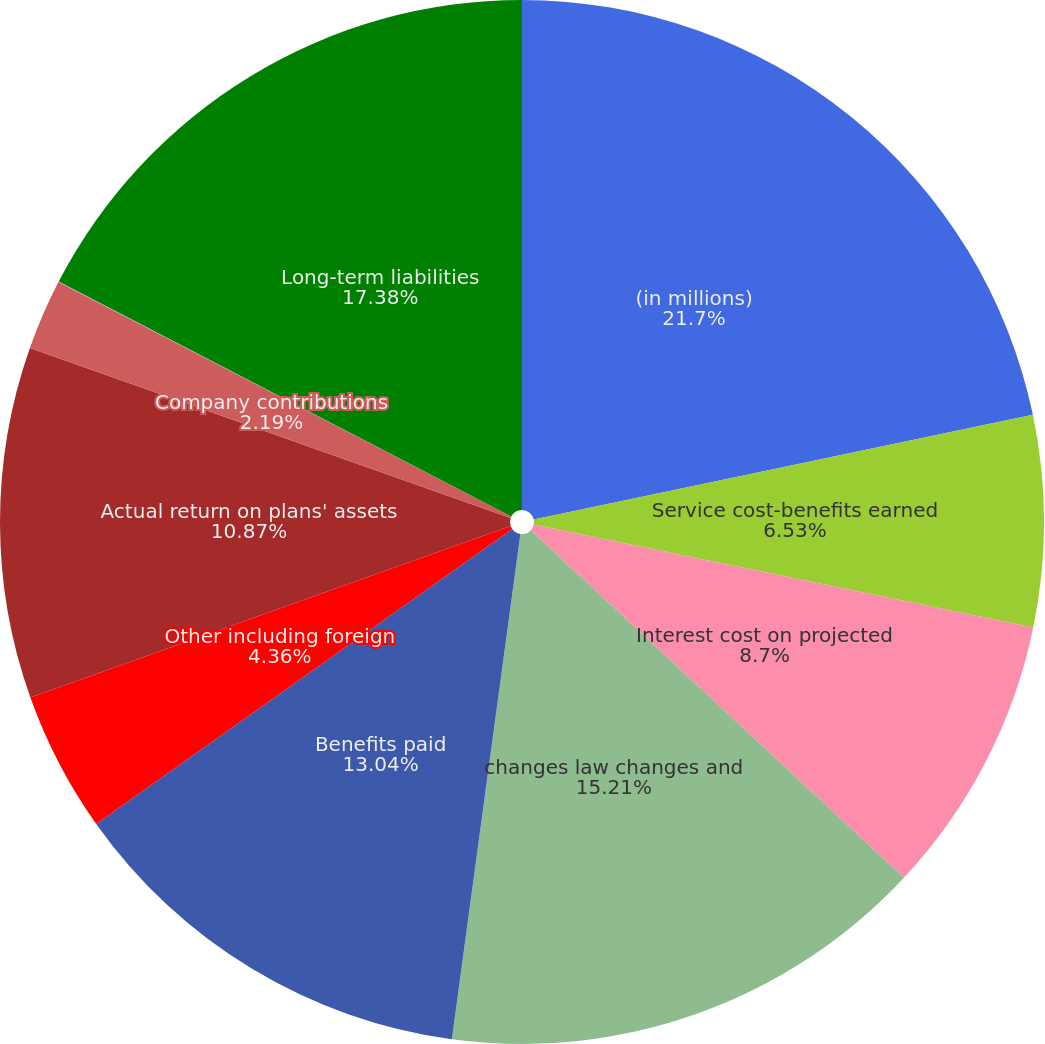<chart> <loc_0><loc_0><loc_500><loc_500><pie_chart><fcel>(in millions)<fcel>Service cost-benefits earned<fcel>Interest cost on projected<fcel>changes law changes and<fcel>Benefits paid<fcel>Other including foreign<fcel>Actual return on plans' assets<fcel>Company contributions<fcel>Short-term liabilities<fcel>Long-term liabilities<nl><fcel>21.71%<fcel>6.53%<fcel>8.7%<fcel>15.21%<fcel>13.04%<fcel>4.36%<fcel>10.87%<fcel>2.19%<fcel>0.02%<fcel>17.38%<nl></chart> 